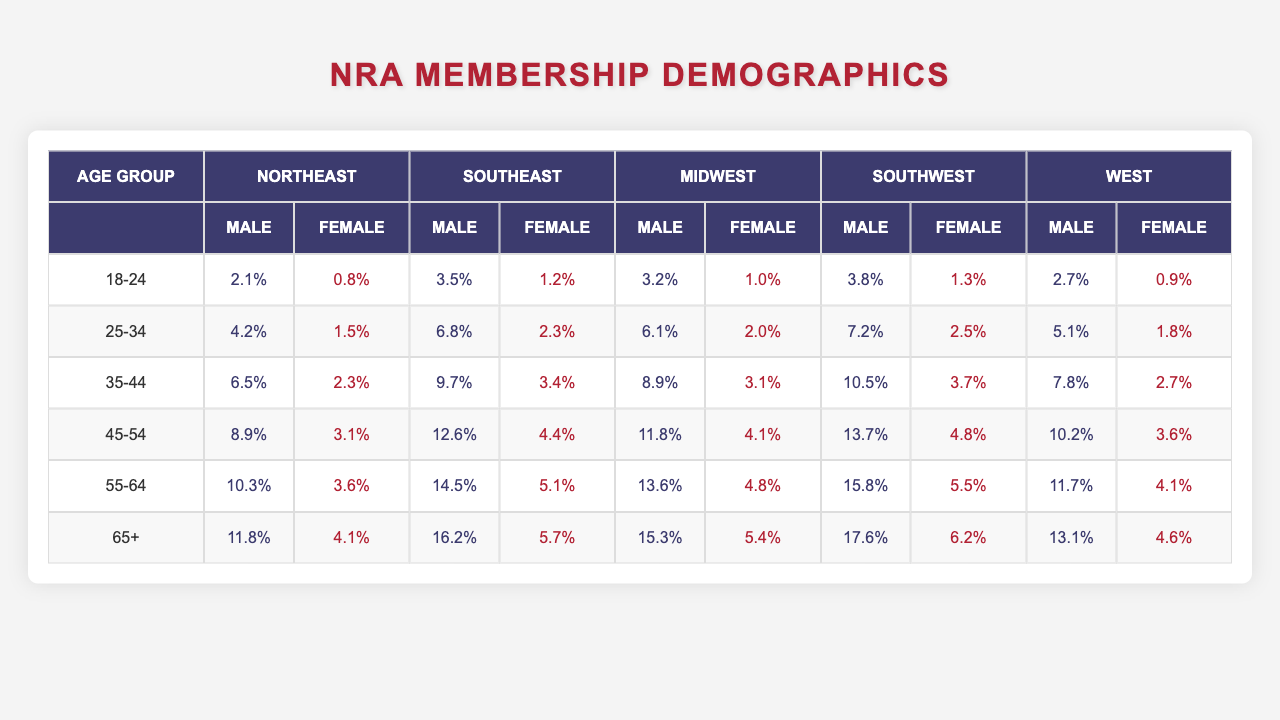What is the percentage of male members in the Southeast aged 65 and older? According to the table, the percentage of male members in the Southeast aged 65 and older is 16.2%.
Answer: 16.2% Which age group has the highest percentage of female members in the Midwest? The age group with the highest percentage of female members in the Midwest is 45-54, with 4.1%.
Answer: 4.1% What is the total percentage of male members across all regions in the age group 35-44? The total percentage for male members aged 35-44 is the sum of male percentages from all regions: 6.5 (Northeast) + 9.7 (Southeast) + 8.9 (Midwest) + 10.5 (Southwest) + 7.8 (West) = 43.4%.
Answer: 43.4% Is the percentage of female members in the 55-64 age group higher in the Southwest compared to the Midwest? In the Southwest, the percentage is 5.5% while in the Midwest it is 4.8%, so 5.5% > 4.8%, making it true that the Southwest has a higher percentage of female members in this age group.
Answer: Yes What is the difference between the percentage of male members in the 25-34 age group from the Southeast and the percentage of female members in the same age group from the West? The percentage of male members in the Southeast aged 25-34 is 6.8%, while the percentage of female members in the West for the same age group is 1.8%. The difference is 6.8% - 1.8% = 5.0%.
Answer: 5.0% Which region has the greatest percentage of male members in the age group 45-54? The Southwest region has the greatest percentage of male members in the age group 45-54 at 13.7%.
Answer: 13.7% What average percentage of female members can be calculated for ages 18-24 across all regions? The percentages are 0.8 (Northeast) + 1.2 (Southeast) + 1.0 (Midwest) + 1.3 (Southwest) + 0.9 (West). The average is (0.8 + 1.2 + 1.0 + 1.3 + 0.9)/5 = 1.24%.
Answer: 1.24% In the 65+ age group, is there any region where the percentage of female members exceeds 6%? Yes, the Southeast region has a female percentage of 5.7%, the Southwest has 6.2%, making it true since it exceeds 6%.
Answer: Yes What is the sum of percentages for male members in both the Northeast and West for the age group 55-64? The percentage for males in the Northeast is 10.3% and in the West is 11.7%, summing them gives 10.3 + 11.7 = 22.0%.
Answer: 22.0% Is the sum of female percentages in the age group 45-54 from the Southeast and Midwest greater than the female percentage in the same age group from the West? The Southeast has 4.4% and the Midwest has 4.1%, summing them gives 4.4 + 4.1 = 8.5%, while the West has 3.6%. Since 8.5% > 3.6%, this is true.
Answer: Yes 